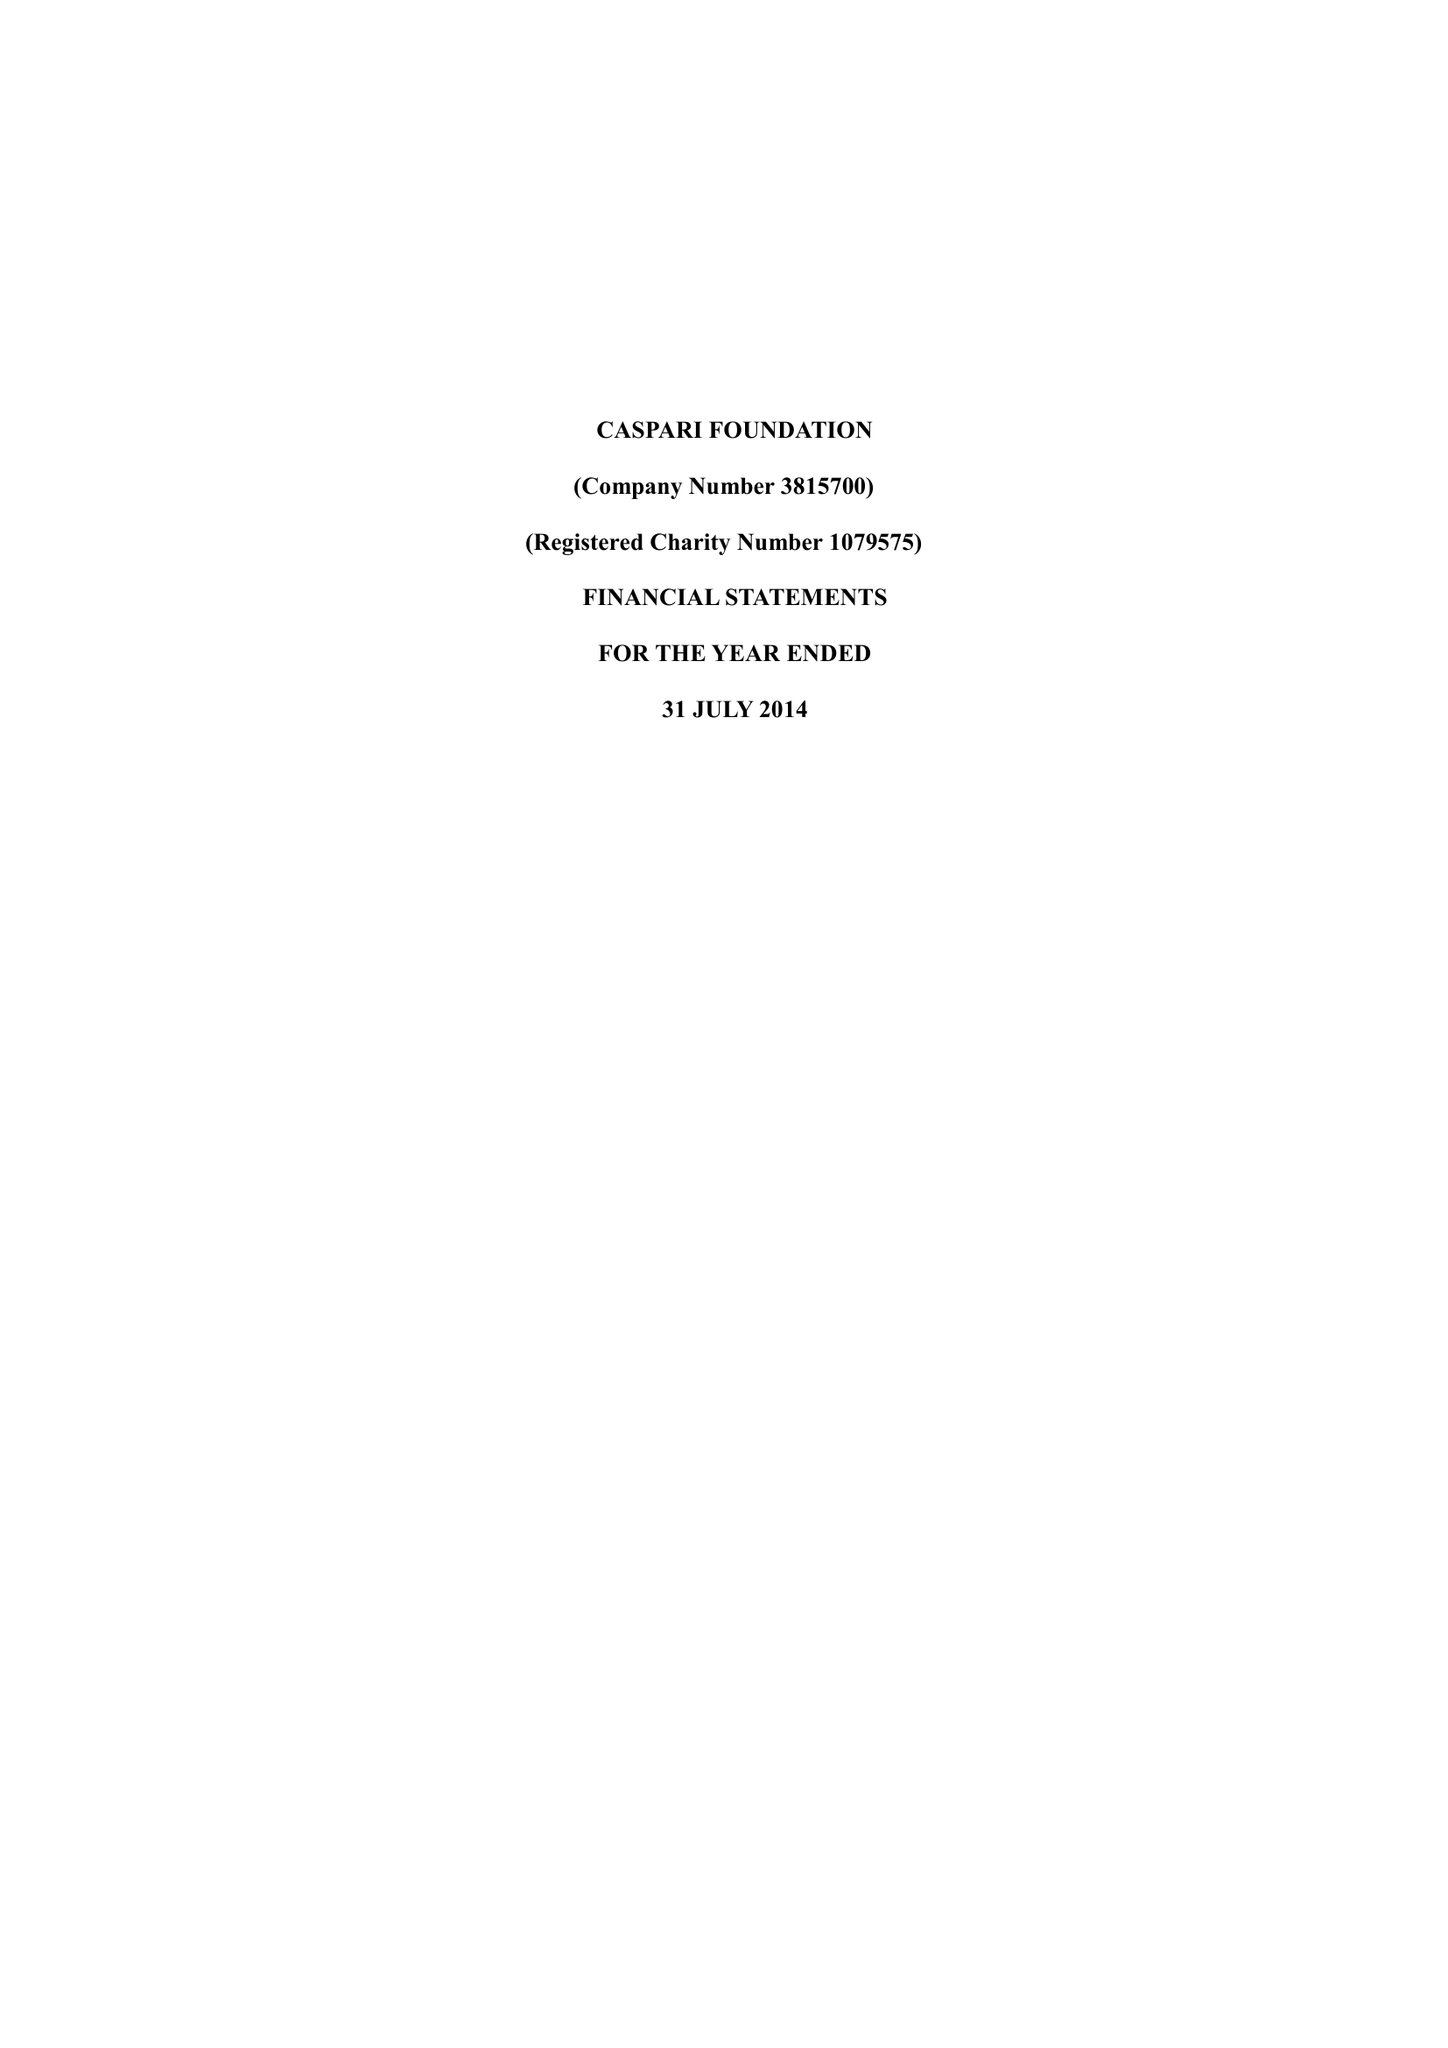What is the value for the address__postcode?
Answer the question using a single word or phrase. N4 2DA 